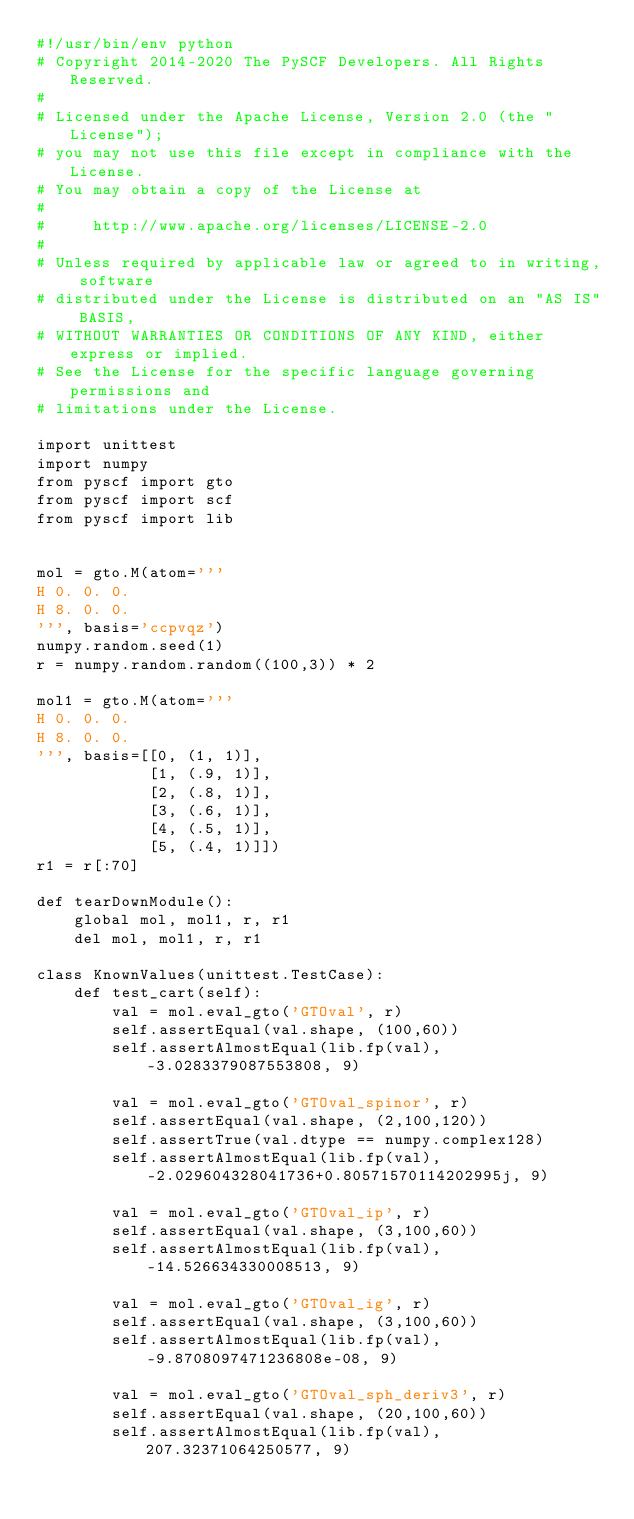<code> <loc_0><loc_0><loc_500><loc_500><_Python_>#!/usr/bin/env python
# Copyright 2014-2020 The PySCF Developers. All Rights Reserved.
#
# Licensed under the Apache License, Version 2.0 (the "License");
# you may not use this file except in compliance with the License.
# You may obtain a copy of the License at
#
#     http://www.apache.org/licenses/LICENSE-2.0
#
# Unless required by applicable law or agreed to in writing, software
# distributed under the License is distributed on an "AS IS" BASIS,
# WITHOUT WARRANTIES OR CONDITIONS OF ANY KIND, either express or implied.
# See the License for the specific language governing permissions and
# limitations under the License.

import unittest
import numpy
from pyscf import gto
from pyscf import scf
from pyscf import lib


mol = gto.M(atom='''
H 0. 0. 0.
H 8. 0. 0.
''', basis='ccpvqz')
numpy.random.seed(1)
r = numpy.random.random((100,3)) * 2

mol1 = gto.M(atom='''
H 0. 0. 0.
H 8. 0. 0.
''', basis=[[0, (1, 1)],
            [1, (.9, 1)],
            [2, (.8, 1)],
            [3, (.6, 1)],
            [4, (.5, 1)],
            [5, (.4, 1)]])
r1 = r[:70]

def tearDownModule():
    global mol, mol1, r, r1
    del mol, mol1, r, r1

class KnownValues(unittest.TestCase):
    def test_cart(self):
        val = mol.eval_gto('GTOval', r)
        self.assertEqual(val.shape, (100,60))
        self.assertAlmostEqual(lib.fp(val), -3.0283379087553808, 9)

        val = mol.eval_gto('GTOval_spinor', r)
        self.assertEqual(val.shape, (2,100,120))
        self.assertTrue(val.dtype == numpy.complex128)
        self.assertAlmostEqual(lib.fp(val), -2.029604328041736+0.80571570114202995j, 9)

        val = mol.eval_gto('GTOval_ip', r)
        self.assertEqual(val.shape, (3,100,60))
        self.assertAlmostEqual(lib.fp(val), -14.526634330008513, 9)

        val = mol.eval_gto('GTOval_ig', r)
        self.assertEqual(val.shape, (3,100,60))
        self.assertAlmostEqual(lib.fp(val), -9.8708097471236808e-08, 9)

        val = mol.eval_gto('GTOval_sph_deriv3', r)
        self.assertEqual(val.shape, (20,100,60))
        self.assertAlmostEqual(lib.fp(val), 207.32371064250577, 9)
</code> 